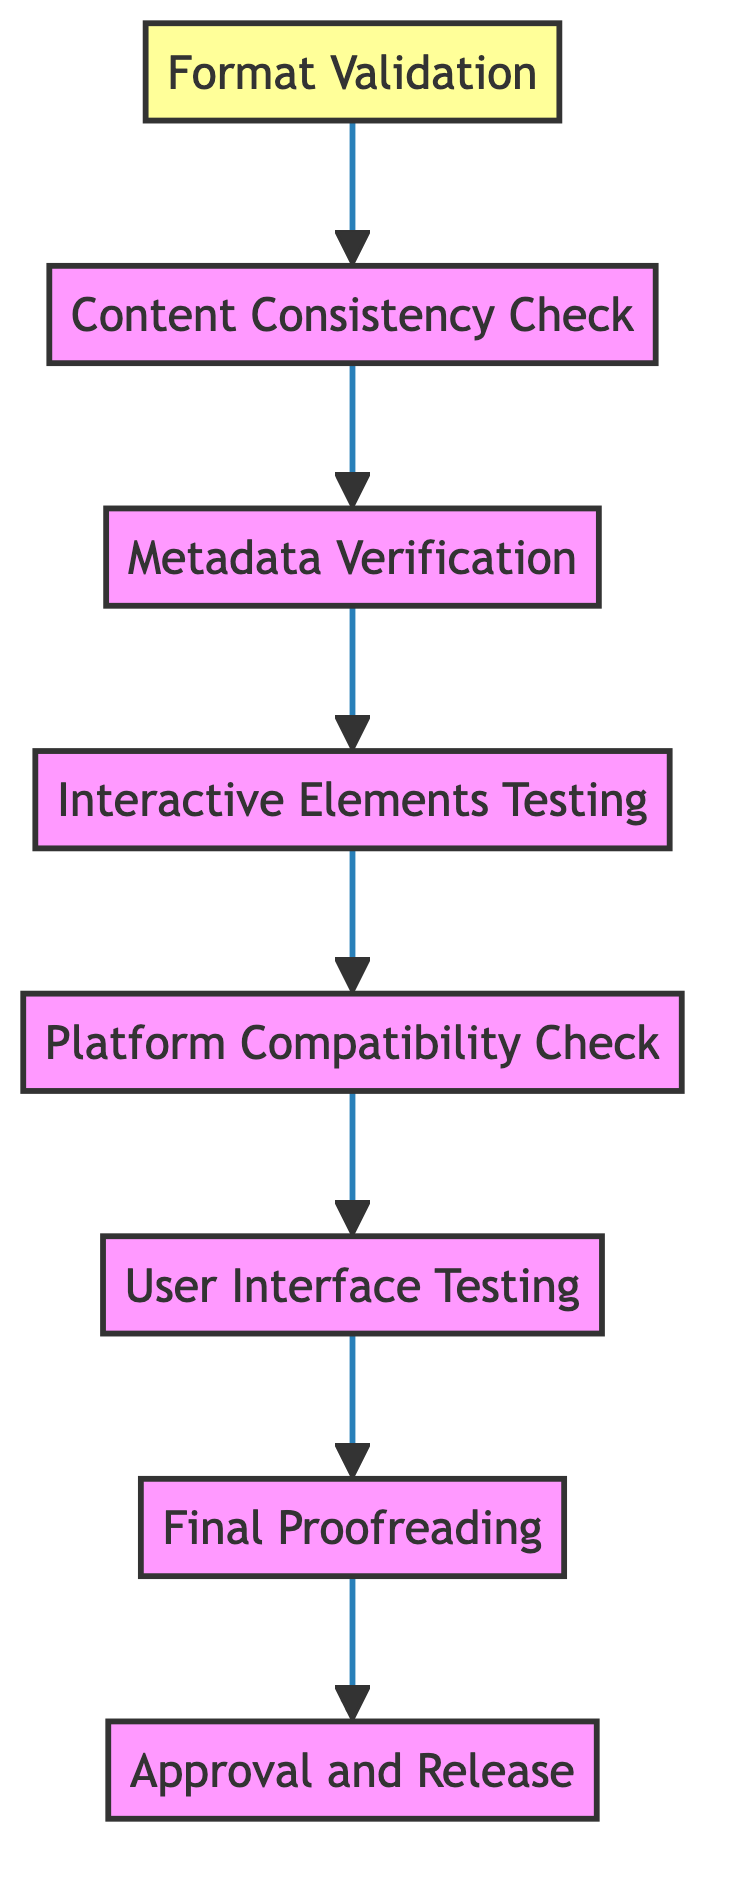What is the first step in the quality assurance workflow? The diagram indicates that the first step in the workflow is "Format Validation," which is the node at the bottom of the flow chart.
Answer: Format Validation How many total nodes are there in the diagram? By counting each unique step listed in the diagram, it can be determined that there are eight distinct nodes.
Answer: 8 What step follows "Content Consistency Check"? Following the "Content Consistency Check" node, the next node in the flow is "Metadata Verification," indicating the subsequent action in the quality assurance process.
Answer: Metadata Verification Which node is directly dependent on "Final Proofreading"? The "Approval and Release" node is directly dependent on the "Final Proofreading" node, making it the next action after proofreading has been completed.
Answer: Approval and Release What is the last step in the quality assurance workflow? The final step, according to the flow chart, is "Approval and Release," which is positioned at the top, concluding the workflow process.
Answer: Approval and Release List the steps in the order they are performed starting from the top. The steps, in order from the top, are: Approval and Release, Final Proofreading, User Interface Testing, Platform Compatibility Check, Interactive Elements Testing, Metadata Verification, Content Consistency Check, Format Validation.
Answer: Approval and Release, Final Proofreading, User Interface Testing, Platform Compatibility Check, Interactive Elements Testing, Metadata Verification, Content Consistency Check, Format Validation What is the relationship between "User Interface Testing" and "Interactive Elements Testing"? "User Interface Testing" is dependent on "Platform Compatibility Check," and "Interactive Elements Testing" precedes it, forming a chain of processes where each depends on the completion of the previous steps. Thus, "Interactive Elements Testing" must be completed before "User Interface Testing" can occur.
Answer: Interactive Elements Testing precedes User Interface Testing Which step requires checking metadata accuracy? The "Metadata Verification" step requires checking the accuracy of metadata, as stated in its description within the diagram.
Answer: Metadata Verification 